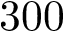Convert formula to latex. <formula><loc_0><loc_0><loc_500><loc_500>3 0 0</formula> 